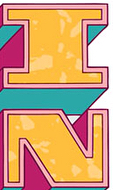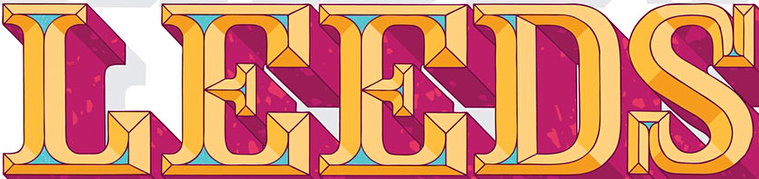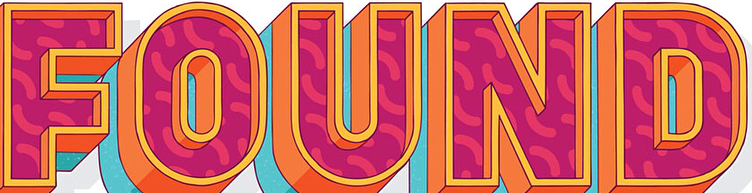Read the text content from these images in order, separated by a semicolon. IN; LEEDS; FOUND 